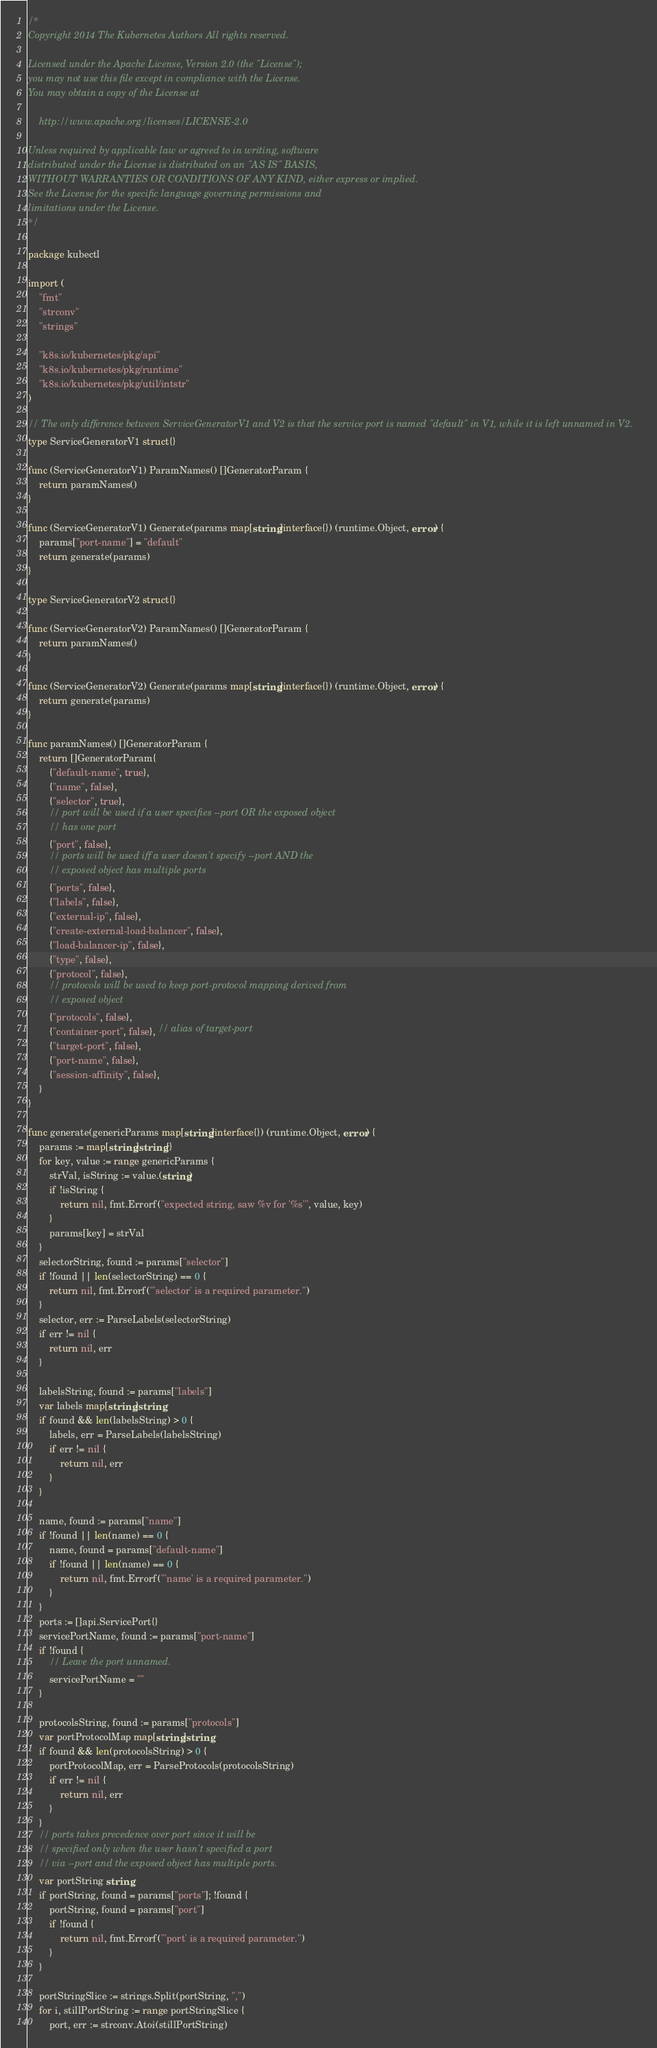Convert code to text. <code><loc_0><loc_0><loc_500><loc_500><_Go_>/*
Copyright 2014 The Kubernetes Authors All rights reserved.

Licensed under the Apache License, Version 2.0 (the "License");
you may not use this file except in compliance with the License.
You may obtain a copy of the License at

    http://www.apache.org/licenses/LICENSE-2.0

Unless required by applicable law or agreed to in writing, software
distributed under the License is distributed on an "AS IS" BASIS,
WITHOUT WARRANTIES OR CONDITIONS OF ANY KIND, either express or implied.
See the License for the specific language governing permissions and
limitations under the License.
*/

package kubectl

import (
	"fmt"
	"strconv"
	"strings"

	"k8s.io/kubernetes/pkg/api"
	"k8s.io/kubernetes/pkg/runtime"
	"k8s.io/kubernetes/pkg/util/intstr"
)

// The only difference between ServiceGeneratorV1 and V2 is that the service port is named "default" in V1, while it is left unnamed in V2.
type ServiceGeneratorV1 struct{}

func (ServiceGeneratorV1) ParamNames() []GeneratorParam {
	return paramNames()
}

func (ServiceGeneratorV1) Generate(params map[string]interface{}) (runtime.Object, error) {
	params["port-name"] = "default"
	return generate(params)
}

type ServiceGeneratorV2 struct{}

func (ServiceGeneratorV2) ParamNames() []GeneratorParam {
	return paramNames()
}

func (ServiceGeneratorV2) Generate(params map[string]interface{}) (runtime.Object, error) {
	return generate(params)
}

func paramNames() []GeneratorParam {
	return []GeneratorParam{
		{"default-name", true},
		{"name", false},
		{"selector", true},
		// port will be used if a user specifies --port OR the exposed object
		// has one port
		{"port", false},
		// ports will be used iff a user doesn't specify --port AND the
		// exposed object has multiple ports
		{"ports", false},
		{"labels", false},
		{"external-ip", false},
		{"create-external-load-balancer", false},
		{"load-balancer-ip", false},
		{"type", false},
		{"protocol", false},
		// protocols will be used to keep port-protocol mapping derived from
		// exposed object
		{"protocols", false},
		{"container-port", false}, // alias of target-port
		{"target-port", false},
		{"port-name", false},
		{"session-affinity", false},
	}
}

func generate(genericParams map[string]interface{}) (runtime.Object, error) {
	params := map[string]string{}
	for key, value := range genericParams {
		strVal, isString := value.(string)
		if !isString {
			return nil, fmt.Errorf("expected string, saw %v for '%s'", value, key)
		}
		params[key] = strVal
	}
	selectorString, found := params["selector"]
	if !found || len(selectorString) == 0 {
		return nil, fmt.Errorf("'selector' is a required parameter.")
	}
	selector, err := ParseLabels(selectorString)
	if err != nil {
		return nil, err
	}

	labelsString, found := params["labels"]
	var labels map[string]string
	if found && len(labelsString) > 0 {
		labels, err = ParseLabels(labelsString)
		if err != nil {
			return nil, err
		}
	}

	name, found := params["name"]
	if !found || len(name) == 0 {
		name, found = params["default-name"]
		if !found || len(name) == 0 {
			return nil, fmt.Errorf("'name' is a required parameter.")
		}
	}
	ports := []api.ServicePort{}
	servicePortName, found := params["port-name"]
	if !found {
		// Leave the port unnamed.
		servicePortName = ""
	}

	protocolsString, found := params["protocols"]
	var portProtocolMap map[string]string
	if found && len(protocolsString) > 0 {
		portProtocolMap, err = ParseProtocols(protocolsString)
		if err != nil {
			return nil, err
		}
	}
	// ports takes precedence over port since it will be
	// specified only when the user hasn't specified a port
	// via --port and the exposed object has multiple ports.
	var portString string
	if portString, found = params["ports"]; !found {
		portString, found = params["port"]
		if !found {
			return nil, fmt.Errorf("'port' is a required parameter.")
		}
	}

	portStringSlice := strings.Split(portString, ",")
	for i, stillPortString := range portStringSlice {
		port, err := strconv.Atoi(stillPortString)</code> 